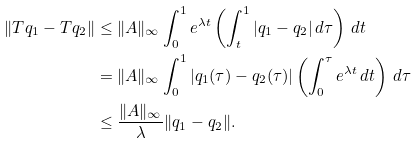Convert formula to latex. <formula><loc_0><loc_0><loc_500><loc_500>\| T q _ { 1 } - T q _ { 2 } \| & \leq \| A \| _ { \infty } \int _ { 0 } ^ { 1 } e ^ { \lambda t } \left ( \int _ { t } ^ { 1 } | q _ { 1 } - q _ { 2 } | \, d \tau \right ) \, d t \\ & = \| A \| _ { \infty } \int _ { 0 } ^ { 1 } | q _ { 1 } ( \tau ) - q _ { 2 } ( \tau ) | \left ( \int _ { 0 } ^ { \tau } e ^ { \lambda t } \, d t \right ) \, d \tau \\ & \leq \frac { \| A \| _ { \infty } } { \lambda } \| q _ { 1 } - q _ { 2 } \| .</formula> 